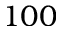Convert formula to latex. <formula><loc_0><loc_0><loc_500><loc_500>1 0 0</formula> 